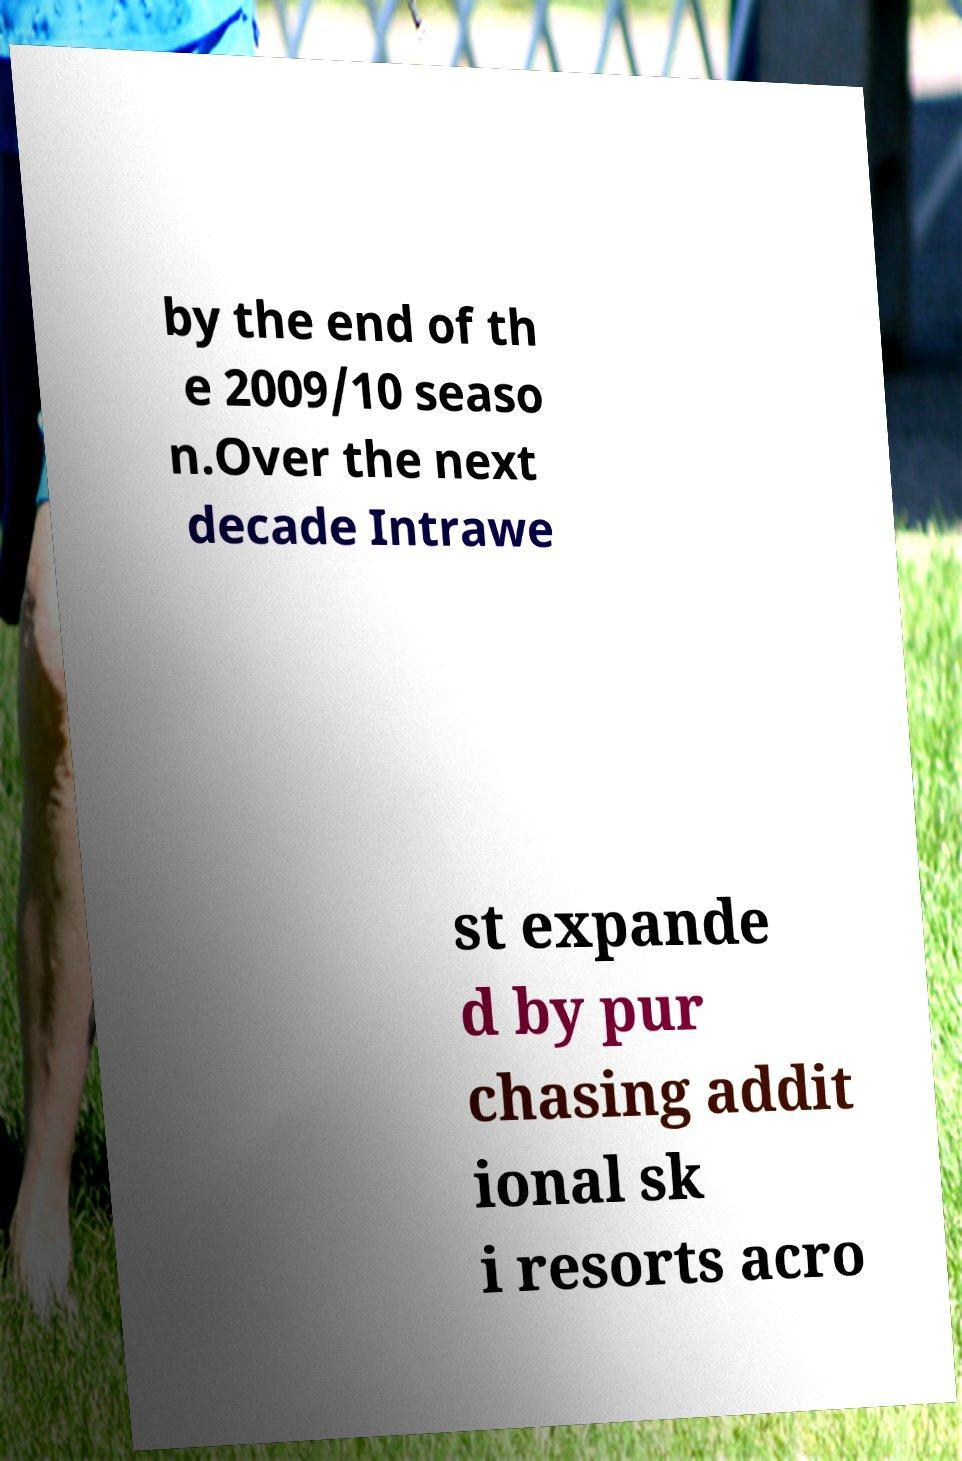Please identify and transcribe the text found in this image. by the end of th e 2009/10 seaso n.Over the next decade Intrawe st expande d by pur chasing addit ional sk i resorts acro 